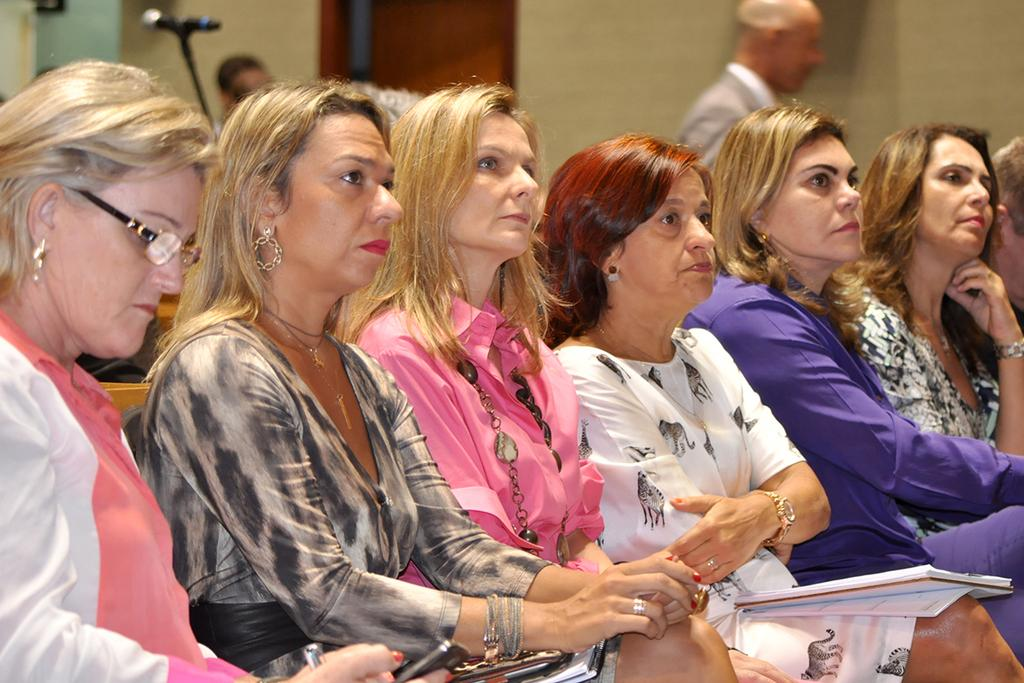What is happening in the foreground of the picture? There are women sitting in the foreground of the picture. What can be seen in the background of the picture? There is a man, a mic, two heads of the person, a door, and a wall in the background of the picture. How many cows are present in the picture? There are no cows present in the picture. What type of vest is the man wearing in the background of the picture? There is no vest visible in the picture; the man in the background is not wearing a vest. 